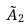<formula> <loc_0><loc_0><loc_500><loc_500>\tilde { A } _ { 2 }</formula> 